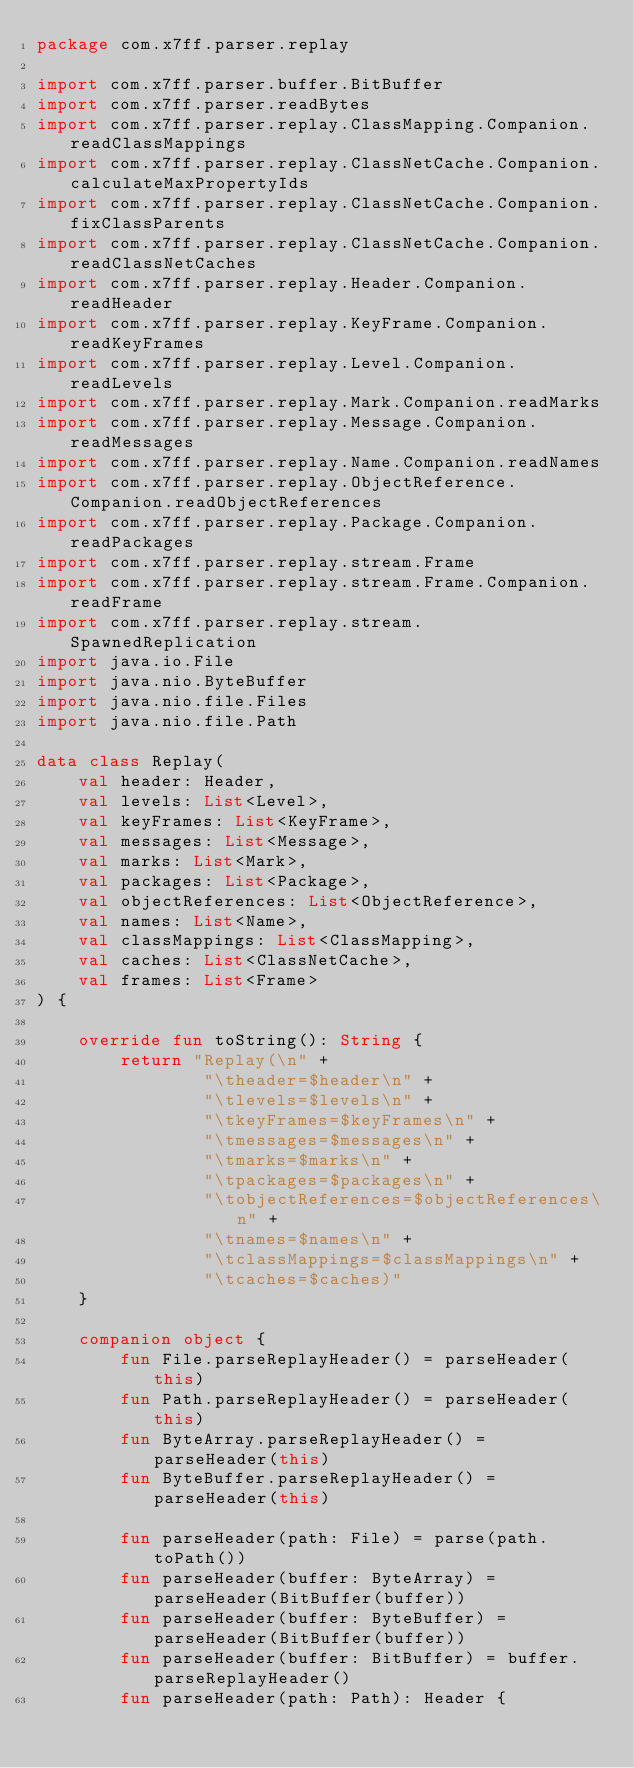<code> <loc_0><loc_0><loc_500><loc_500><_Kotlin_>package com.x7ff.parser.replay

import com.x7ff.parser.buffer.BitBuffer
import com.x7ff.parser.readBytes
import com.x7ff.parser.replay.ClassMapping.Companion.readClassMappings
import com.x7ff.parser.replay.ClassNetCache.Companion.calculateMaxPropertyIds
import com.x7ff.parser.replay.ClassNetCache.Companion.fixClassParents
import com.x7ff.parser.replay.ClassNetCache.Companion.readClassNetCaches
import com.x7ff.parser.replay.Header.Companion.readHeader
import com.x7ff.parser.replay.KeyFrame.Companion.readKeyFrames
import com.x7ff.parser.replay.Level.Companion.readLevels
import com.x7ff.parser.replay.Mark.Companion.readMarks
import com.x7ff.parser.replay.Message.Companion.readMessages
import com.x7ff.parser.replay.Name.Companion.readNames
import com.x7ff.parser.replay.ObjectReference.Companion.readObjectReferences
import com.x7ff.parser.replay.Package.Companion.readPackages
import com.x7ff.parser.replay.stream.Frame
import com.x7ff.parser.replay.stream.Frame.Companion.readFrame
import com.x7ff.parser.replay.stream.SpawnedReplication
import java.io.File
import java.nio.ByteBuffer
import java.nio.file.Files
import java.nio.file.Path

data class Replay(
    val header: Header,
    val levels: List<Level>,
    val keyFrames: List<KeyFrame>,
    val messages: List<Message>,
    val marks: List<Mark>,
    val packages: List<Package>,
    val objectReferences: List<ObjectReference>,
    val names: List<Name>,
    val classMappings: List<ClassMapping>,
    val caches: List<ClassNetCache>,
    val frames: List<Frame>
) {

    override fun toString(): String {
        return "Replay(\n" +
                "\theader=$header\n" +
                "\tlevels=$levels\n" +
                "\tkeyFrames=$keyFrames\n" +
                "\tmessages=$messages\n" +
                "\tmarks=$marks\n" +
                "\tpackages=$packages\n" +
                "\tobjectReferences=$objectReferences\n" +
                "\tnames=$names\n" +
                "\tclassMappings=$classMappings\n" +
                "\tcaches=$caches)"
    }

    companion object {
        fun File.parseReplayHeader() = parseHeader(this)
        fun Path.parseReplayHeader() = parseHeader(this)
        fun ByteArray.parseReplayHeader() = parseHeader(this)
        fun ByteBuffer.parseReplayHeader() = parseHeader(this)

        fun parseHeader(path: File) = parse(path.toPath())
        fun parseHeader(buffer: ByteArray) = parseHeader(BitBuffer(buffer))
        fun parseHeader(buffer: ByteBuffer) = parseHeader(BitBuffer(buffer))
        fun parseHeader(buffer: BitBuffer) = buffer.parseReplayHeader()
        fun parseHeader(path: Path): Header {</code> 